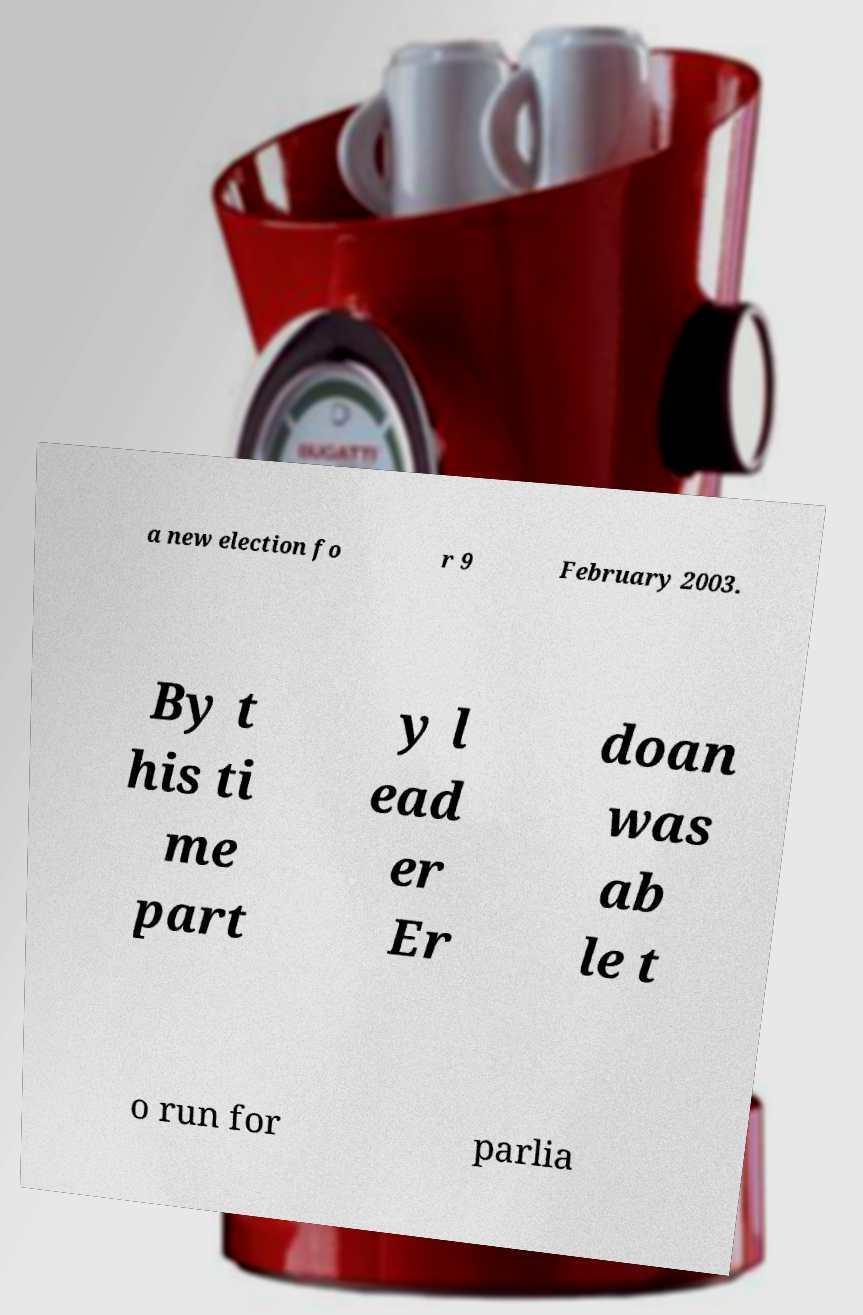Could you assist in decoding the text presented in this image and type it out clearly? a new election fo r 9 February 2003. By t his ti me part y l ead er Er doan was ab le t o run for parlia 